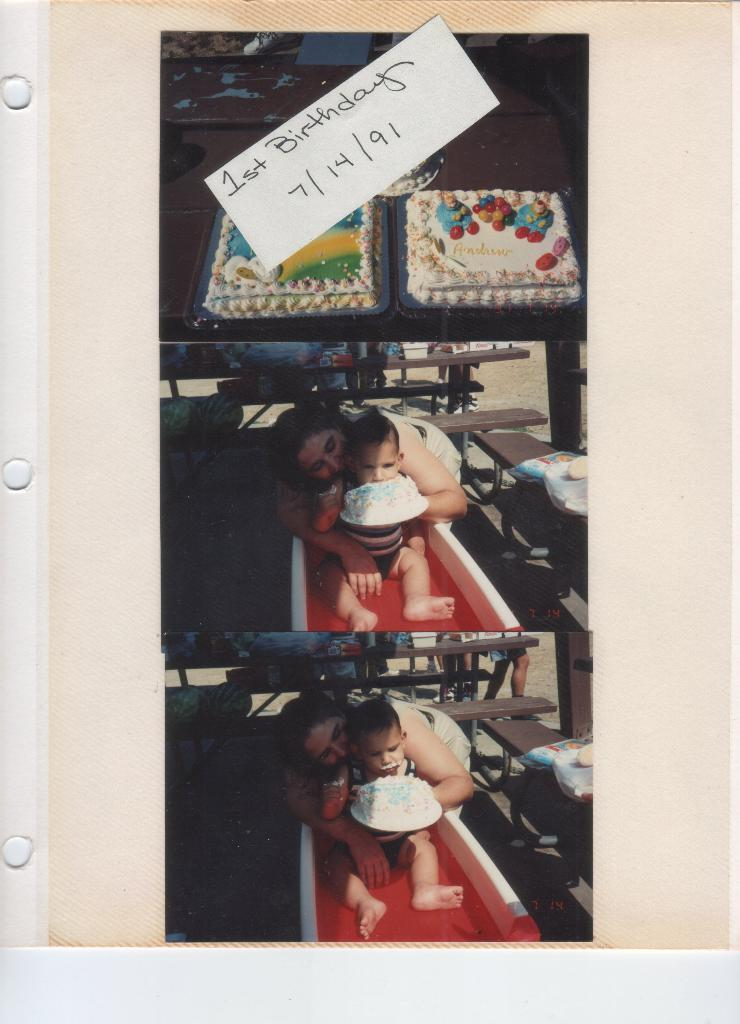What object is present in the image that typically holds a photo? There is a photo frame in the image. Who or what can be seen in the photo frame? There are two people and cakes in the photo frame. What else is present in the photo frame besides the people and cakes? There is a paper with text in the photo frame. What type of copper material is present in the image? There is no copper material present in the image. Can you describe the boy in the image? There is no boy present in the image; it features a photo frame with two people and cakes. 